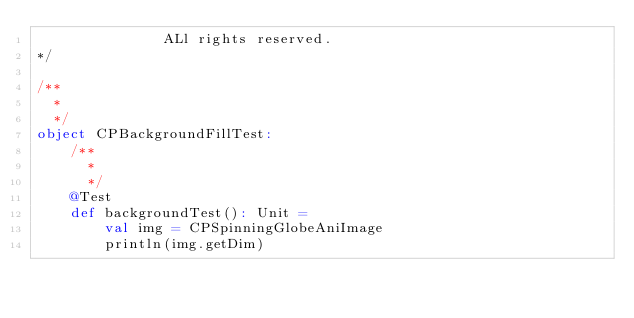Convert code to text. <code><loc_0><loc_0><loc_500><loc_500><_Scala_>               ALl rights reserved.
*/

/**
  *
  */
object CPBackgroundFillTest:
    /**
      *
      */
    @Test
    def backgroundTest(): Unit =
        val img = CPSpinningGlobeAniImage
        println(img.getDim)
</code> 